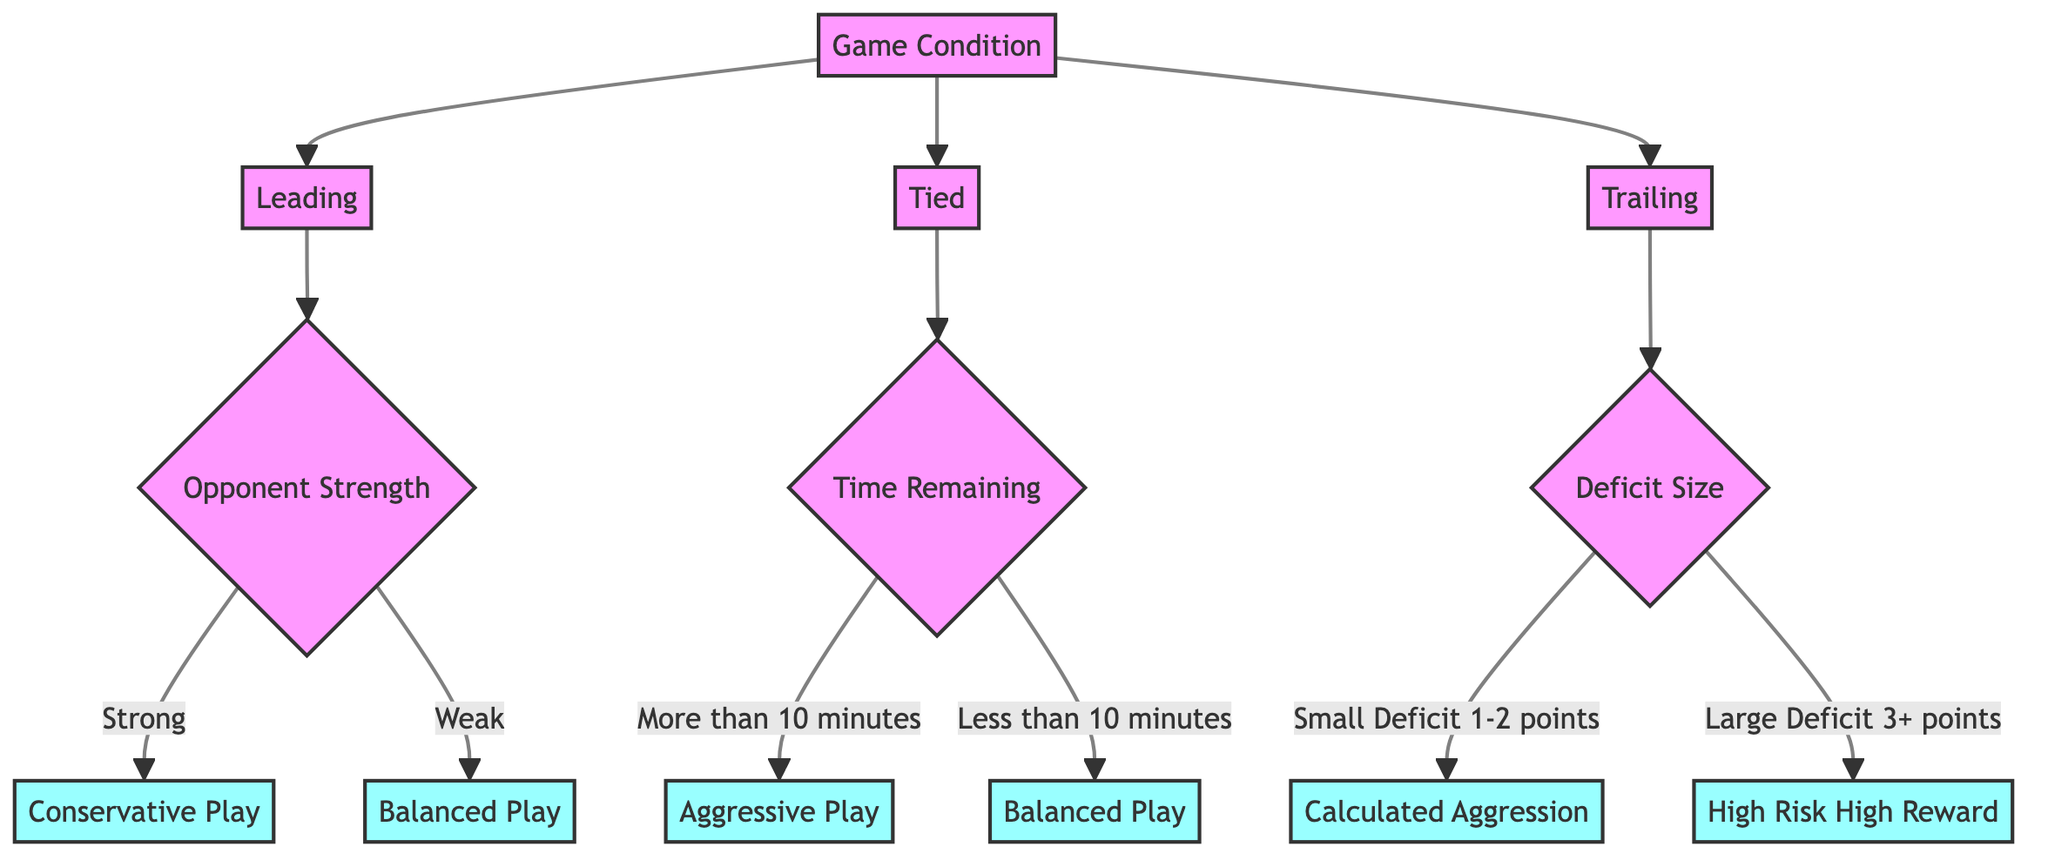What are the three initial game conditions? The tree starts with three main branches representing "Leading," "Tied," and "Trailing."
Answer: Leading, Tied, Trailing What action is recommended when trailing with a small deficit? If the condition is "Trailing" and the "Deficit Size" is a "Small Deficit (1-2 points)," the action is "Calculated Aggression."
Answer: Calculated Aggression What do teams do when leading against a strong opponent? When a team is "Leading" and facing a "Strong" opponent, the recommended strategy is "Conservative Play."
Answer: Conservative Play How many total actions are specified in the diagram? There are six actions outlined in the decision tree: Conservative Play, Balanced Play, Aggressive Play, High Risk High Reward, and Calculated Aggression.
Answer: 6 Which action is taken when the game is tied with less than 10 minutes remaining? If the game is "Tied" and there is "Less than 10 minutes," the action is "Balanced Play."
Answer: Balanced Play What happens if the team is trailing by a large deficit? The strategy when "Trailing" with a "Large Deficit (3+ points)" is "High Risk High Reward," indicating an aggressive approach is required.
Answer: High Risk High Reward Which game condition leads to Conservative Play? "Leading" against a "Strong" opponent leads to the action "Conservative Play."
Answer: Leading, Strong What is the action for a tied game with more than 10 minutes remaining? The action to be taken in a tied game scenario with "More than 10 minutes" left is "Aggressive Play."
Answer: Aggressive Play What is the relationship between the number of opponent strength options and the corresponding actions in the leading condition? There are two options for opponent strength (Strong and Weak) leading to two actions (Conservative Play and Balanced Play) when in the "Leading" condition.
Answer: 2 options, 2 actions 